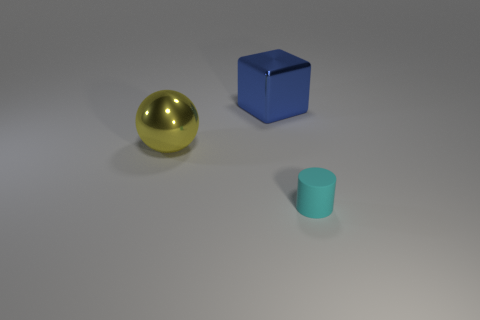Is there any other thing that is the same material as the cylinder?
Keep it short and to the point. No. Is the number of large yellow objects on the left side of the small cylinder greater than the number of tiny purple spheres?
Give a very brief answer. Yes. Is the material of the large thing that is on the left side of the big blue object the same as the small object?
Your response must be concise. No. There is a thing that is on the right side of the metal object that is behind the large shiny object that is in front of the blue thing; what size is it?
Ensure brevity in your answer.  Small. There is a thing that is the same material as the large cube; what is its size?
Provide a short and direct response. Large. The thing that is in front of the blue block and behind the small cyan thing is what color?
Offer a very short reply. Yellow. What material is the thing that is in front of the metallic sphere?
Your answer should be very brief. Rubber. What number of objects are objects right of the yellow ball or large balls?
Provide a succinct answer. 3. Is the number of cyan cylinders that are on the right side of the large blue object the same as the number of cyan cylinders?
Ensure brevity in your answer.  Yes. Does the cylinder have the same size as the sphere?
Your response must be concise. No. 